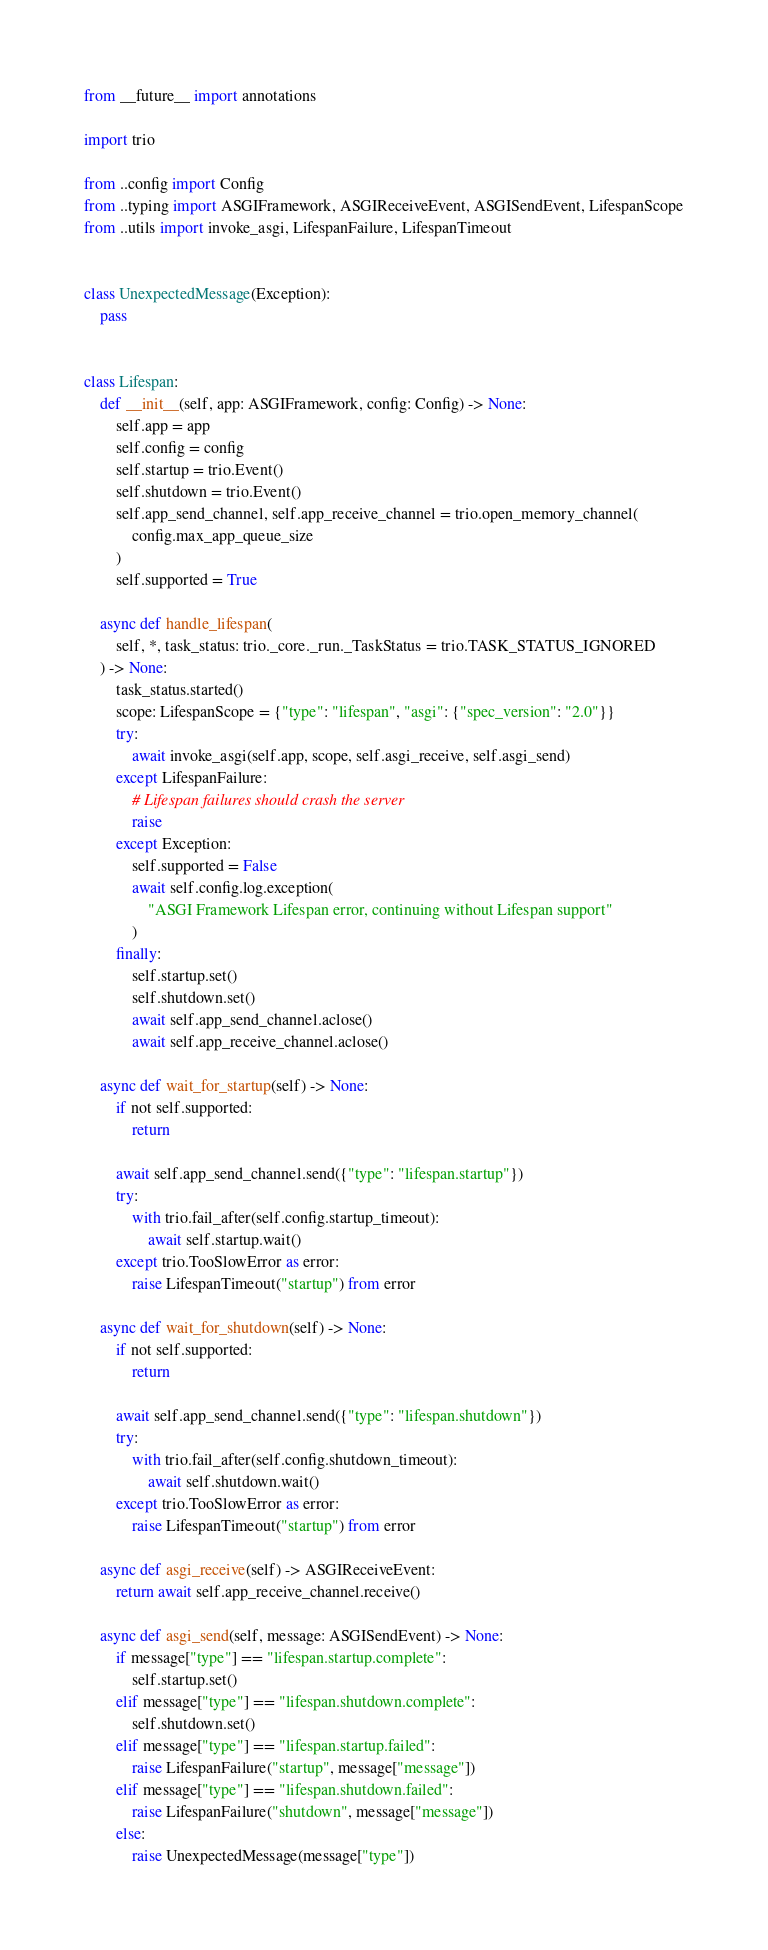Convert code to text. <code><loc_0><loc_0><loc_500><loc_500><_Python_>from __future__ import annotations

import trio

from ..config import Config
from ..typing import ASGIFramework, ASGIReceiveEvent, ASGISendEvent, LifespanScope
from ..utils import invoke_asgi, LifespanFailure, LifespanTimeout


class UnexpectedMessage(Exception):
    pass


class Lifespan:
    def __init__(self, app: ASGIFramework, config: Config) -> None:
        self.app = app
        self.config = config
        self.startup = trio.Event()
        self.shutdown = trio.Event()
        self.app_send_channel, self.app_receive_channel = trio.open_memory_channel(
            config.max_app_queue_size
        )
        self.supported = True

    async def handle_lifespan(
        self, *, task_status: trio._core._run._TaskStatus = trio.TASK_STATUS_IGNORED
    ) -> None:
        task_status.started()
        scope: LifespanScope = {"type": "lifespan", "asgi": {"spec_version": "2.0"}}
        try:
            await invoke_asgi(self.app, scope, self.asgi_receive, self.asgi_send)
        except LifespanFailure:
            # Lifespan failures should crash the server
            raise
        except Exception:
            self.supported = False
            await self.config.log.exception(
                "ASGI Framework Lifespan error, continuing without Lifespan support"
            )
        finally:
            self.startup.set()
            self.shutdown.set()
            await self.app_send_channel.aclose()
            await self.app_receive_channel.aclose()

    async def wait_for_startup(self) -> None:
        if not self.supported:
            return

        await self.app_send_channel.send({"type": "lifespan.startup"})
        try:
            with trio.fail_after(self.config.startup_timeout):
                await self.startup.wait()
        except trio.TooSlowError as error:
            raise LifespanTimeout("startup") from error

    async def wait_for_shutdown(self) -> None:
        if not self.supported:
            return

        await self.app_send_channel.send({"type": "lifespan.shutdown"})
        try:
            with trio.fail_after(self.config.shutdown_timeout):
                await self.shutdown.wait()
        except trio.TooSlowError as error:
            raise LifespanTimeout("startup") from error

    async def asgi_receive(self) -> ASGIReceiveEvent:
        return await self.app_receive_channel.receive()

    async def asgi_send(self, message: ASGISendEvent) -> None:
        if message["type"] == "lifespan.startup.complete":
            self.startup.set()
        elif message["type"] == "lifespan.shutdown.complete":
            self.shutdown.set()
        elif message["type"] == "lifespan.startup.failed":
            raise LifespanFailure("startup", message["message"])
        elif message["type"] == "lifespan.shutdown.failed":
            raise LifespanFailure("shutdown", message["message"])
        else:
            raise UnexpectedMessage(message["type"])
</code> 